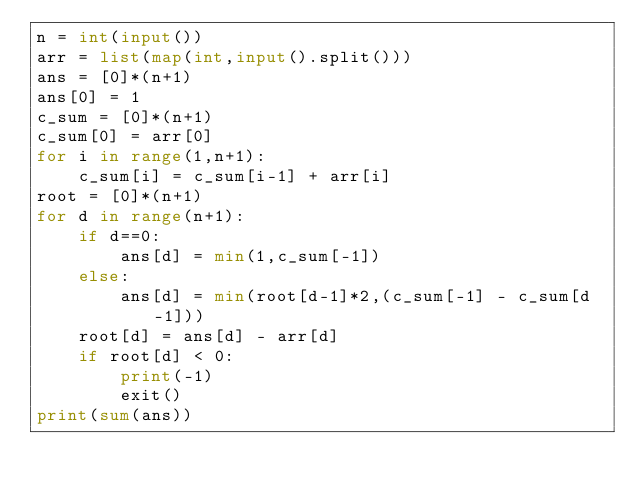Convert code to text. <code><loc_0><loc_0><loc_500><loc_500><_Python_>n = int(input())
arr = list(map(int,input().split()))
ans = [0]*(n+1)
ans[0] = 1
c_sum = [0]*(n+1)
c_sum[0] = arr[0]
for i in range(1,n+1):
    c_sum[i] = c_sum[i-1] + arr[i]
root = [0]*(n+1)
for d in range(n+1):
    if d==0:
        ans[d] = min(1,c_sum[-1])
    else:
        ans[d] = min(root[d-1]*2,(c_sum[-1] - c_sum[d-1]))
    root[d] = ans[d] - arr[d]
    if root[d] < 0:
        print(-1)
        exit()
print(sum(ans))


</code> 